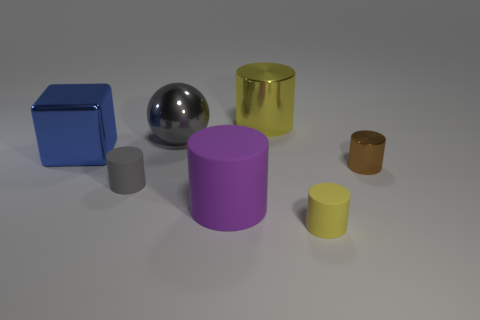There is a rubber cylinder that is the same color as the ball; what is its size?
Offer a very short reply. Small. There is a object that is the same color as the ball; what shape is it?
Your answer should be compact. Cylinder. The shiny block is what size?
Ensure brevity in your answer.  Large. How many blue metal blocks are the same size as the brown thing?
Provide a short and direct response. 0. Is the color of the big rubber cylinder the same as the large block?
Keep it short and to the point. No. Is the yellow thing in front of the small metal cylinder made of the same material as the large cylinder left of the large yellow metallic cylinder?
Provide a succinct answer. Yes. Is the number of large yellow shiny cylinders greater than the number of tiny yellow rubber blocks?
Provide a short and direct response. Yes. Are there any other things that are the same color as the tiny metal thing?
Keep it short and to the point. No. Does the blue object have the same material as the brown cylinder?
Keep it short and to the point. Yes. Is the number of red shiny cylinders less than the number of tiny gray objects?
Keep it short and to the point. Yes. 